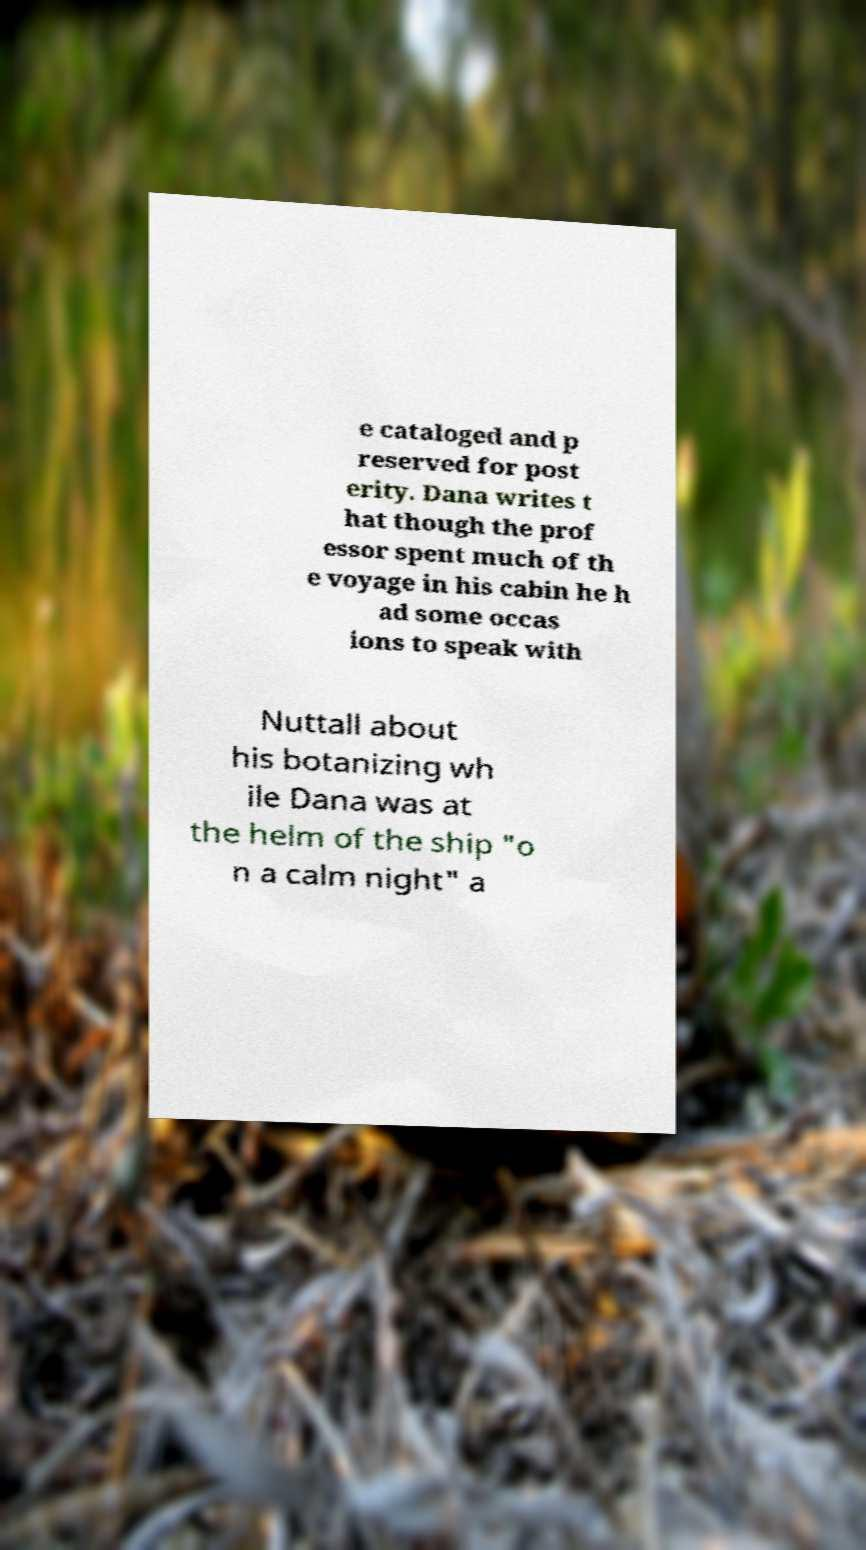Could you extract and type out the text from this image? e cataloged and p reserved for post erity. Dana writes t hat though the prof essor spent much of th e voyage in his cabin he h ad some occas ions to speak with Nuttall about his botanizing wh ile Dana was at the helm of the ship "o n a calm night" a 